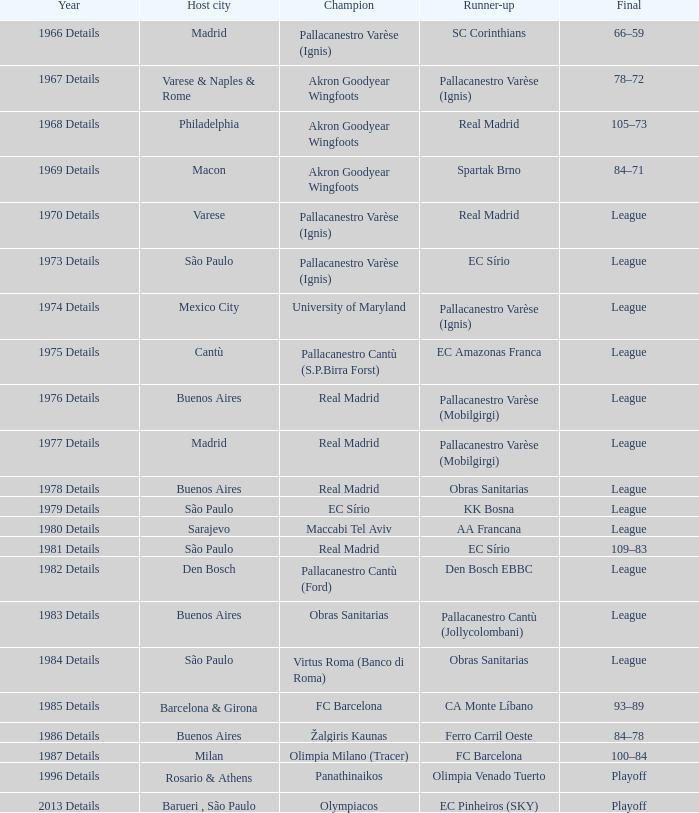What year was the International Cup that was won by Akron Goodyear Wingfoots and had Real Madrid as runner-up? 1968 Details. 